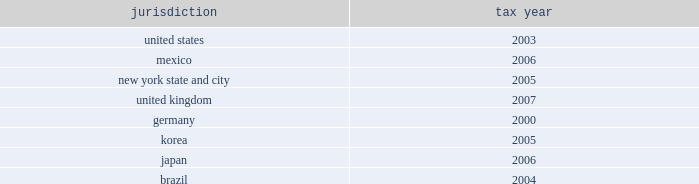The company is currently under audit by the internal revenue service and other major taxing jurisdictions around the world .
It is thus reasonably possible that significant changes in the gross balance of unrecognized tax benefits may occur within the next 12 months , but the company does not expect such audits to result in amounts that would cause a significant change to its effective tax rate , other than the following items .
The company is currently at irs appeals for the years 1999 20132002 .
One of the issues relates to the timing of the inclusion of interchange fees received by the company relating to credit card purchases by its cardholders .
It is reasonably possible that within the next 12 months the company can either reach agreement on this issue at appeals or decide to litigate the issue .
This issue is presently being litigated by another company in a united states tax court case .
The gross uncertain tax position for this item at december 31 , 2008 is $ 542 million .
Since this is a temporary difference , the only effect to the company 2019s effective tax rate would be due to net interest and state tax rate differentials .
If the reserve were to be released , the tax benefit could be as much as $ 168 million .
In addition , the company expects to conclude the irs audit of its u.s .
Federal consolidated income tax returns for the years 2003 20132005 within the next 12 months .
The gross uncertain tax position at december 31 , 2008 for the items expected to be resolved is approximately $ 350 million plus gross interest of $ 70 million .
The potential net tax benefit to continuing operations could be approximately $ 325 million .
The following are the major tax jurisdictions in which the company and its affiliates operate and the earliest tax year subject to examination: .
Foreign pretax earnings approximated $ 10.3 billion in 2008 , $ 9.1 billion in 2007 , and $ 13.6 billion in 2006 ( $ 5.1 billion , $ 0.7 billion and $ 0.9 billion of which , respectively , are in discontinued operations ) .
As a u.s .
Corporation , citigroup and its u.s .
Subsidiaries are subject to u.s .
Taxation currently on all foreign pretax earnings earned by a foreign branch .
Pretax earnings of a foreign subsidiary or affiliate are subject to u.s .
Taxation when effectively repatriated .
The company provides income taxes on the undistributed earnings of non-u.s .
Subsidiaries except to the extent that such earnings are indefinitely invested outside the united states .
At december 31 , 2008 , $ 22.8 billion of accumulated undistributed earnings of non-u.s .
Subsidiaries were indefinitely invested .
At the existing u.s .
Federal income tax rate , additional taxes ( net of u.s .
Foreign tax credits ) of $ 6.1 billion would have to be provided if such earnings were remitted currently .
The current year 2019s effect on the income tax expense from continuing operations is included in the foreign income tax rate differential line in the reconciliation of the federal statutory rate to the company 2019s effective income tax rate on the previous page .
Income taxes are not provided for on the company 2019s savings bank base year bad debt reserves that arose before 1988 because under current u.s .
Tax rules such taxes will become payable only to the extent such amounts are distributed in excess of limits prescribed by federal law .
At december 31 , 2008 , the amount of the base year reserves totaled approximately $ 358 million ( subject to a tax of $ 125 million ) .
The company has no valuation allowance on deferred tax assets at december 31 , 2008 and december 31 , 2007 .
At december 31 , 2008 , the company had a u.s .
Foreign tax-credit carryforward of $ 10.5 billion , $ 0.4 billion whose expiry date is 2016 , $ 5.3 billion whose expiry date is 2017 and $ 4.8 billion whose expiry date is 2018 .
The company has a u.s federal consolidated net operating loss ( nol ) carryforward of approximately $ 13 billion whose expiration date is 2028 .
The company also has a general business credit carryforward of $ 0.6 billion whose expiration dates are 2027-2028 .
The company has state and local net operating loss carryforwards of $ 16.2 billion and $ 4.9 billion in new york state and new york city , respectively .
This consists of $ 2.4 billion and $ 1.2 billion , whose expiration date is 2027 and $ 13.8 billion and $ 3.7 billion whose expiration date is 2028 and for which the company has recorded a deferred-tax asset of $ 1.2 billion , along with less significant net operating losses in various other states for which the company has recorded a deferred-tax asset of $ 399 million and which expire between 2012 and 2028 .
In addition , the company has recorded deferred-tax assets in apb 23 subsidiaries for foreign net operating loss carryforwards of $ 130 million ( which expires in 2018 ) and $ 101 million ( with no expiration ) .
Although realization is not assured , the company believes that the realization of the recognized net deferred tax asset of $ 44.5 billion is more likely than not based on expectations as to future taxable income in the jurisdictions in which it operates and available tax planning strategies , as defined in sfas 109 , that could be implemented if necessary to prevent a carryforward from expiring .
The company 2019s net deferred tax asset ( dta ) of $ 44.5 billion consists of approximately $ 36.5 billion of net u.s .
Federal dtas , $ 4 billion of net state dtas and $ 4 billion of net foreign dtas .
Included in the net federal dta of $ 36.5 billion are deferred tax liabilities of $ 4 billion that will reverse in the relevant carryforward period and may be used to support the dta .
The major components of the u.s .
Federal dta are $ 10.5 billion in foreign tax-credit carryforwards , $ 4.6 billion in a net-operating-loss carryforward , $ 0.6 billion in a general-business-credit carryforward , $ 19.9 billion in net deductions that have not yet been taken on a tax return , and $ 0.9 billion in compensation deductions , which reduced additional paid-in capital in january 2009 and for which sfas 123 ( r ) did not permit any adjustment to such dta at december 31 , 2008 because the related stock compensation was not yet deductible to the company .
In general , citigroup would need to generate approximately $ 85 billion of taxable income during the respective carryforward periods to fully realize its federal , state and local dtas. .
What percent of foreign pretax earnings in 2007 were from discontinued operations? 
Computations: (0.7 / 9.1)
Answer: 0.07692. 